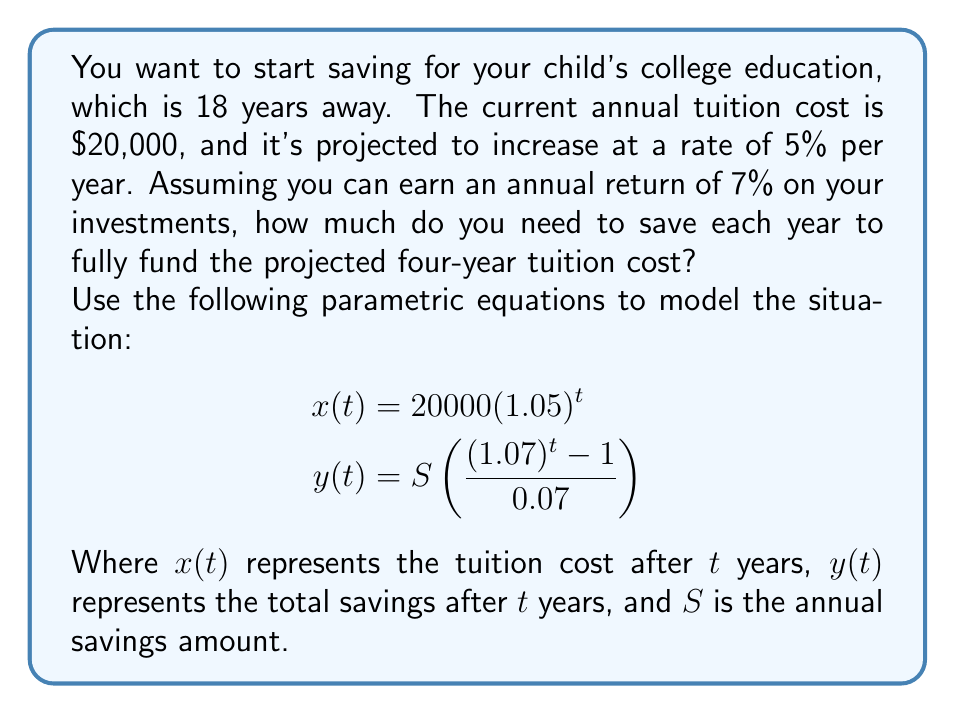Can you solve this math problem? Let's approach this problem step-by-step:

1) First, we need to calculate the total tuition cost for four years of college:

   For year 18: $x(18) = 20000(1.05)^{18} = \$42,995.11$
   For year 19: $x(19) = 20000(1.05)^{19} = \$45,144.86$
   For year 20: $x(20) = 20000(1.05)^{20} = \$47,402.11$
   For year 21: $x(21) = 20000(1.05)^{21} = \$49,772.21$

   Total: $\$185,314.29$

2) Now, we need to find $S$ such that $y(18) = 185,314.29$

3) Substituting into the equation for $y(t)$:

   $$185,314.29 = S\left(\frac{(1.07)^{18} - 1}{0.07}\right)$$

4) Simplify the right side:

   $$185,314.29 = S(33.81557)$$

5) Solve for $S$:

   $$S = \frac{185,314.29}{33.81557} = \$5,480.15$$

Therefore, you need to save $5,480.15 per year to fully fund the projected four-year tuition cost.

6) We can verify this by calculating $y(18)$ with $S = 5,480.15$:

   $$y(18) = 5,480.15\left(\frac{(1.07)^{18} - 1}{0.07}\right) = \$185,314.29$$

   This matches our required total, confirming our calculation.
Answer: $5,480.15 per year 